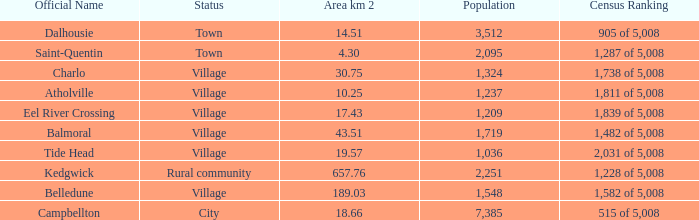When the status is rural community what's the lowest area in kilometers squared? 657.76. 